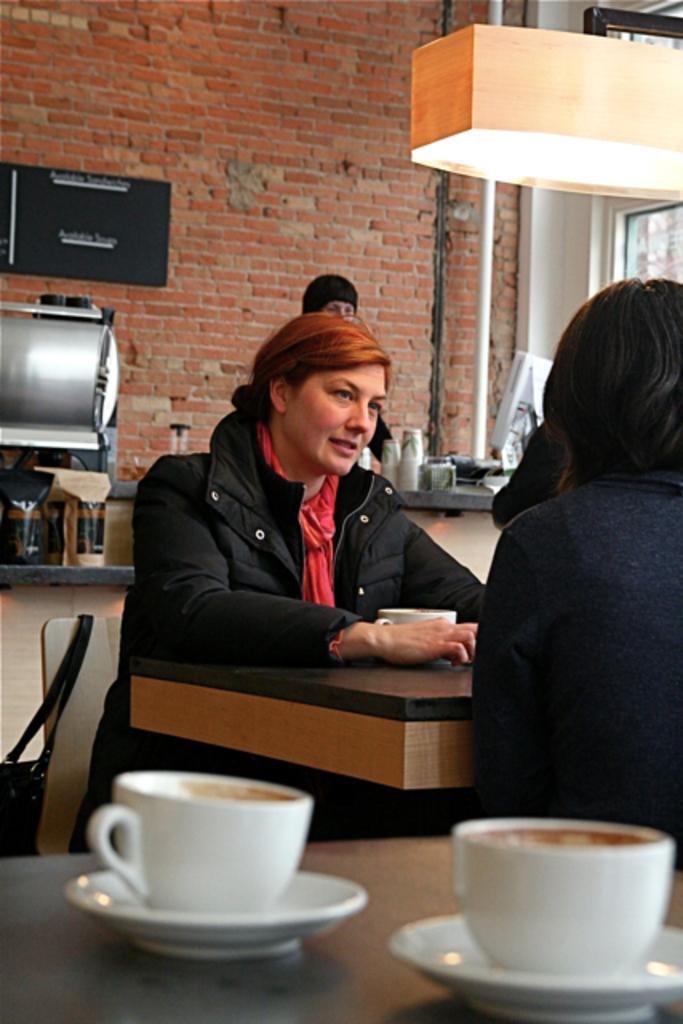How would you summarize this image in a sentence or two? She is sitting in a chair. There is a table. There is a cup and saucer on a table. We can see in the background there is a red wall bricks and monitor. 